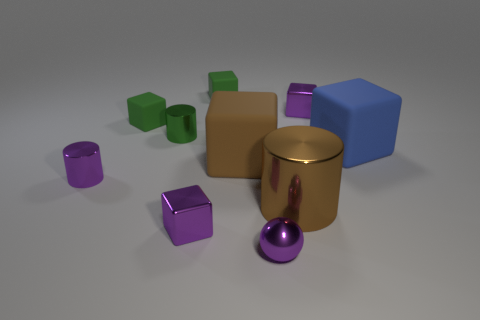Subtract all tiny purple shiny blocks. How many blocks are left? 4 Subtract all purple spheres. How many purple cubes are left? 2 Subtract 1 cylinders. How many cylinders are left? 2 Subtract all brown cylinders. How many cylinders are left? 2 Subtract all balls. How many objects are left? 9 Add 5 blue matte things. How many blue matte things exist? 6 Subtract 1 brown blocks. How many objects are left? 9 Subtract all gray cubes. Subtract all red balls. How many cubes are left? 6 Subtract all purple objects. Subtract all big yellow metal balls. How many objects are left? 6 Add 1 blue rubber objects. How many blue rubber objects are left? 2 